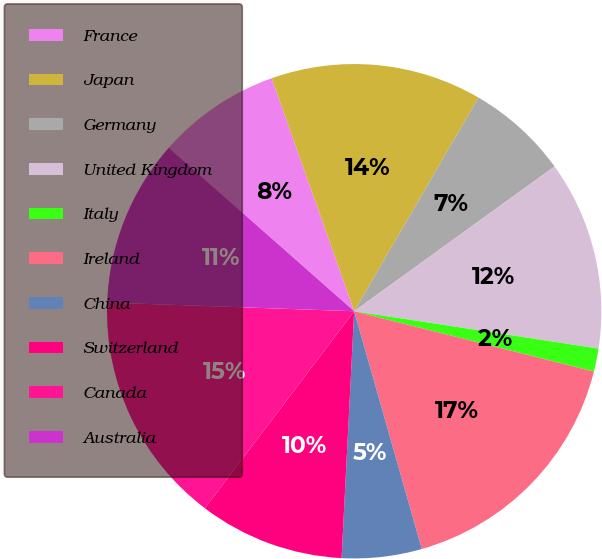Convert chart to OTSL. <chart><loc_0><loc_0><loc_500><loc_500><pie_chart><fcel>France<fcel>Japan<fcel>Germany<fcel>United Kingdom<fcel>Italy<fcel>Ireland<fcel>China<fcel>Switzerland<fcel>Canada<fcel>Australia<nl><fcel>8.08%<fcel>13.8%<fcel>6.65%<fcel>12.37%<fcel>1.51%<fcel>16.66%<fcel>5.22%<fcel>9.51%<fcel>15.23%<fcel>10.94%<nl></chart> 